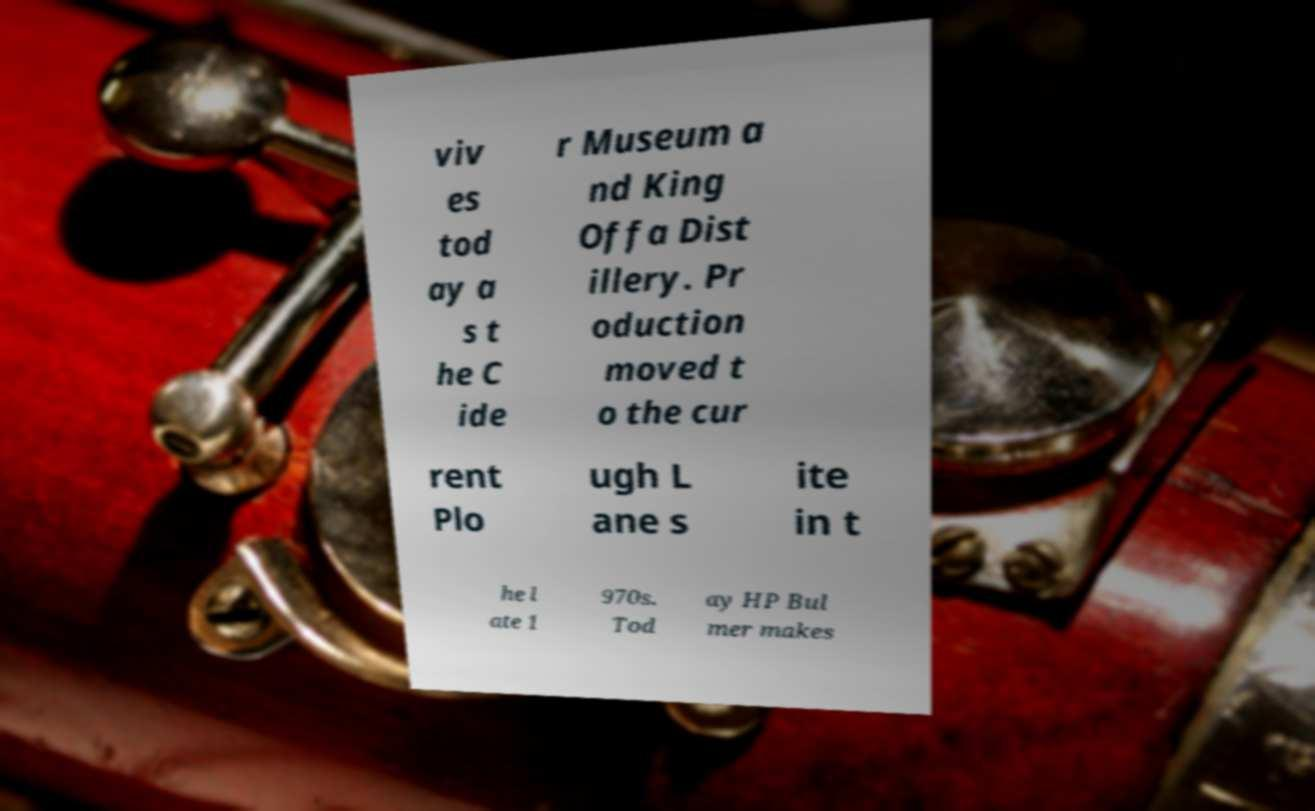What messages or text are displayed in this image? I need them in a readable, typed format. viv es tod ay a s t he C ide r Museum a nd King Offa Dist illery. Pr oduction moved t o the cur rent Plo ugh L ane s ite in t he l ate 1 970s. Tod ay HP Bul mer makes 